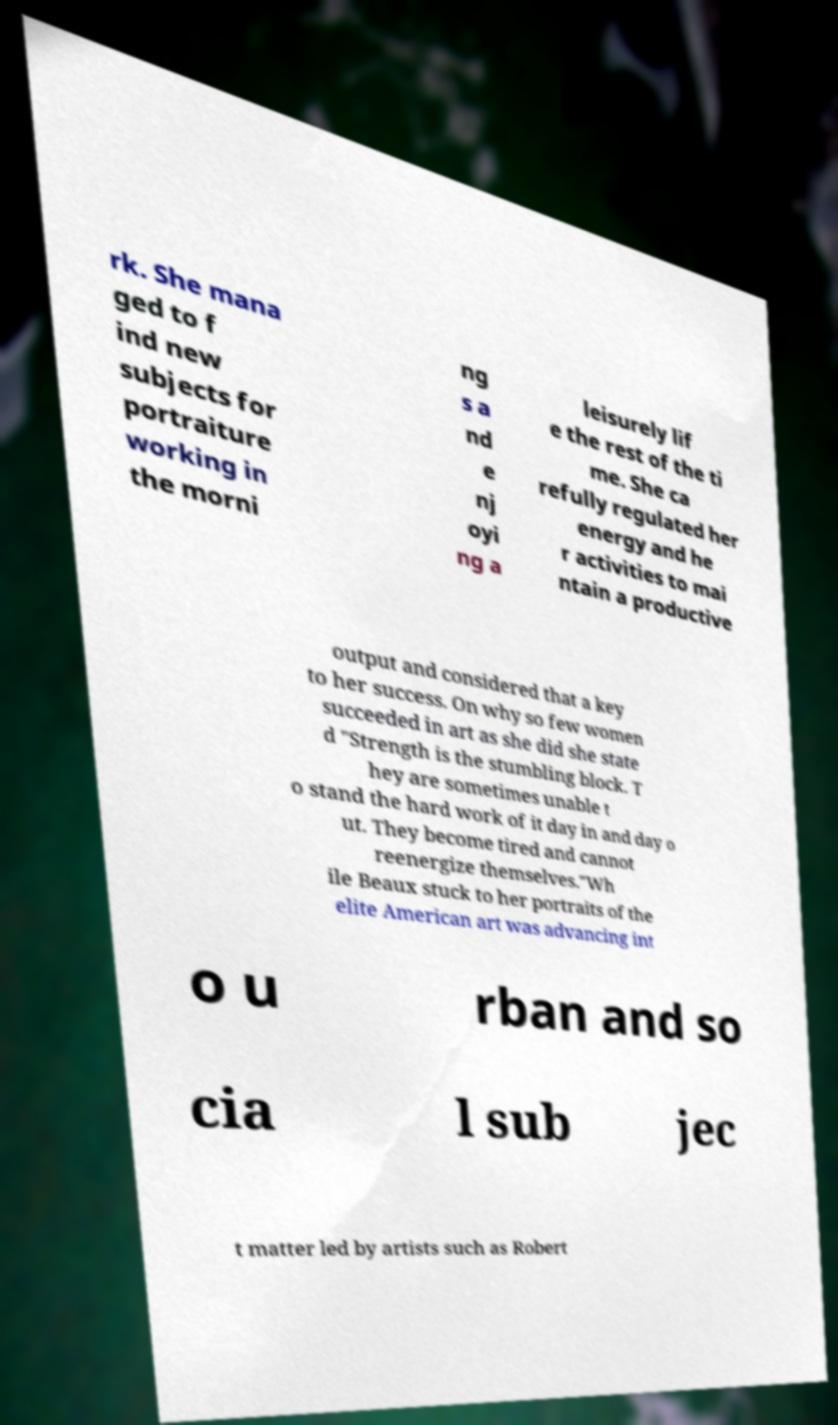Please identify and transcribe the text found in this image. rk. She mana ged to f ind new subjects for portraiture working in the morni ng s a nd e nj oyi ng a leisurely lif e the rest of the ti me. She ca refully regulated her energy and he r activities to mai ntain a productive output and considered that a key to her success. On why so few women succeeded in art as she did she state d "Strength is the stumbling block. T hey are sometimes unable t o stand the hard work of it day in and day o ut. They become tired and cannot reenergize themselves."Wh ile Beaux stuck to her portraits of the elite American art was advancing int o u rban and so cia l sub jec t matter led by artists such as Robert 